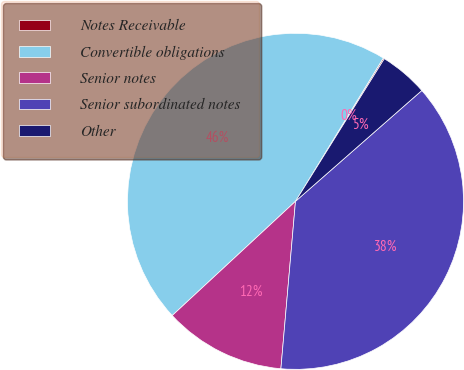Convert chart. <chart><loc_0><loc_0><loc_500><loc_500><pie_chart><fcel>Notes Receivable<fcel>Convertible obligations<fcel>Senior notes<fcel>Senior subordinated notes<fcel>Other<nl><fcel>0.12%<fcel>45.64%<fcel>11.72%<fcel>37.84%<fcel>4.67%<nl></chart> 